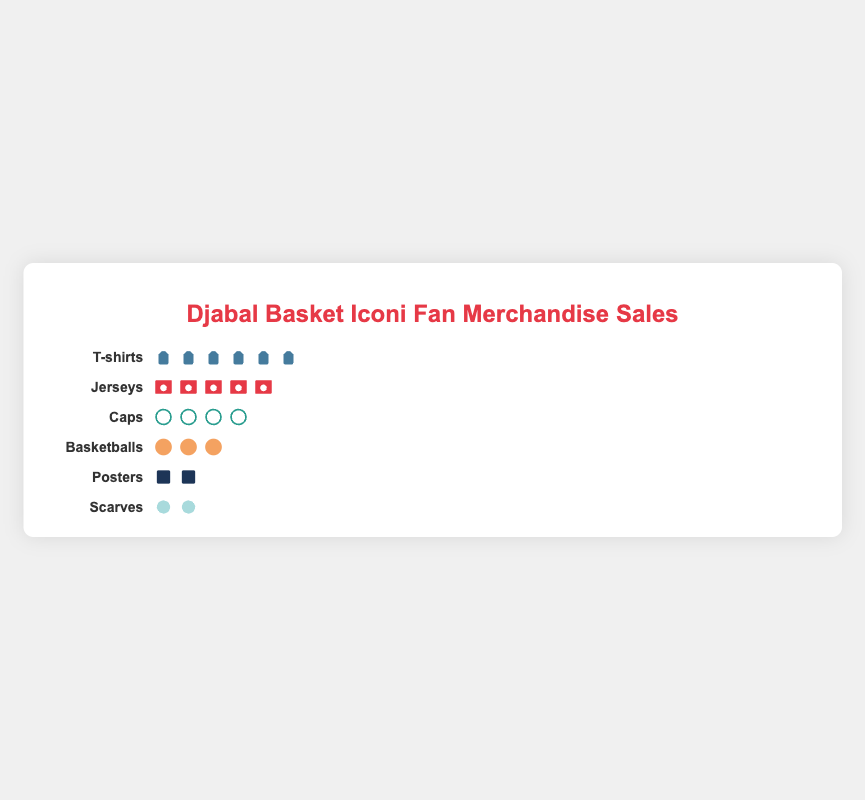What is the title of the figure? The title is located at the top of the figure and is in larger, bold font.
Answer: Djabal Basket Iconi Fan Merchandise Sales Which product category has the most sales? This can be determined by looking for the category with the most icons. The T-shirts category has the most icons.
Answer: T-shirts How many categories are shown in the figure? Count the number of different product categories listed from top to bottom. There are six categories listed.
Answer: Six Which product category sold the least units? Look for the product category with the fewest icons. The Scarves category shows the fewest icons.
Answer: Scarves How many jersey units were sold? Count the number of icons in the Jerseys row. There are five icon units in that row.
Answer: 500 Compare the sales of Caps and Posters. Which category had more sales? Look at the number of icons in each category row: there are four icons for Caps and two for Posters.
Answer: Caps What is the total number of units sold for all categories combined? Count all the icons in each row and add them together. T-shirts (600) + Jerseys (500) + Caps (400) + Basketballs (300) + Posters (200) + Scarves (150) = 2150
Answer: 2150 By how many units do T-shirt sales exceed Poster sales? The T-shirts category has six icons (each representing 100 units), and the Posters category has two icons. 600 - 200 = 400
Answer: 400 How many more units of Basketballs were sold compared to Scarves? The Basketballs category has three icons (300 units), and the Scarves category has two icons (150 units). 300 - 150 = 150
Answer: 150 Which two categories have the closest sales figures? Compare the number of icons. Jerseys have five icons (500 units), and Caps have four icons (400 units), which are closest. The difference is only 100 units.
Answer: Jerseys and Caps 